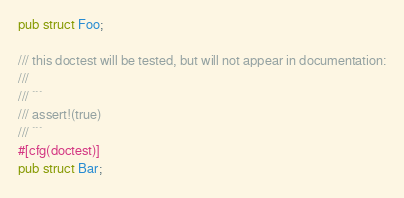<code> <loc_0><loc_0><loc_500><loc_500><_Rust_>pub struct Foo;

/// this doctest will be tested, but will not appear in documentation:
///
/// ```
/// assert!(true)
/// ```
#[cfg(doctest)]
pub struct Bar;
</code> 